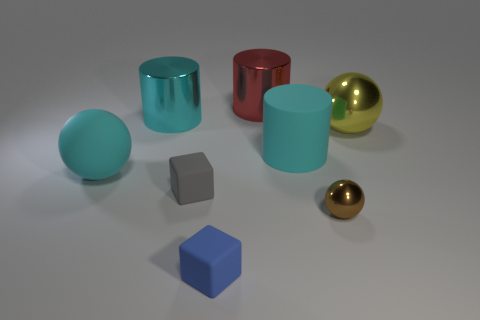Add 1 small brown spheres. How many objects exist? 9 Subtract all cyan rubber cylinders. How many cylinders are left? 2 Add 4 large cyan metallic things. How many large cyan metallic things exist? 5 Subtract all yellow balls. How many balls are left? 2 Subtract 0 purple cylinders. How many objects are left? 8 Subtract all cubes. How many objects are left? 6 Subtract 1 blocks. How many blocks are left? 1 Subtract all blue cylinders. Subtract all blue spheres. How many cylinders are left? 3 Subtract all gray balls. How many cyan cylinders are left? 2 Subtract all small purple matte spheres. Subtract all cyan matte balls. How many objects are left? 7 